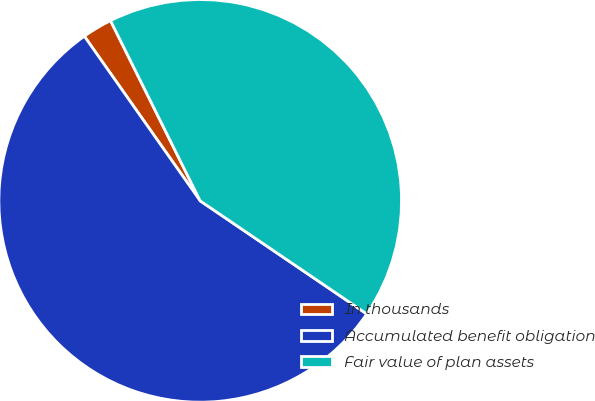<chart> <loc_0><loc_0><loc_500><loc_500><pie_chart><fcel>In thousands<fcel>Accumulated benefit obligation<fcel>Fair value of plan assets<nl><fcel>2.41%<fcel>55.75%<fcel>41.84%<nl></chart> 